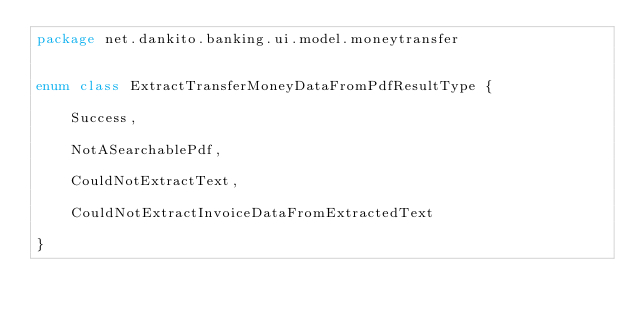<code> <loc_0><loc_0><loc_500><loc_500><_Kotlin_>package net.dankito.banking.ui.model.moneytransfer


enum class ExtractTransferMoneyDataFromPdfResultType {

    Success,

    NotASearchablePdf,

    CouldNotExtractText,

    CouldNotExtractInvoiceDataFromExtractedText

}</code> 